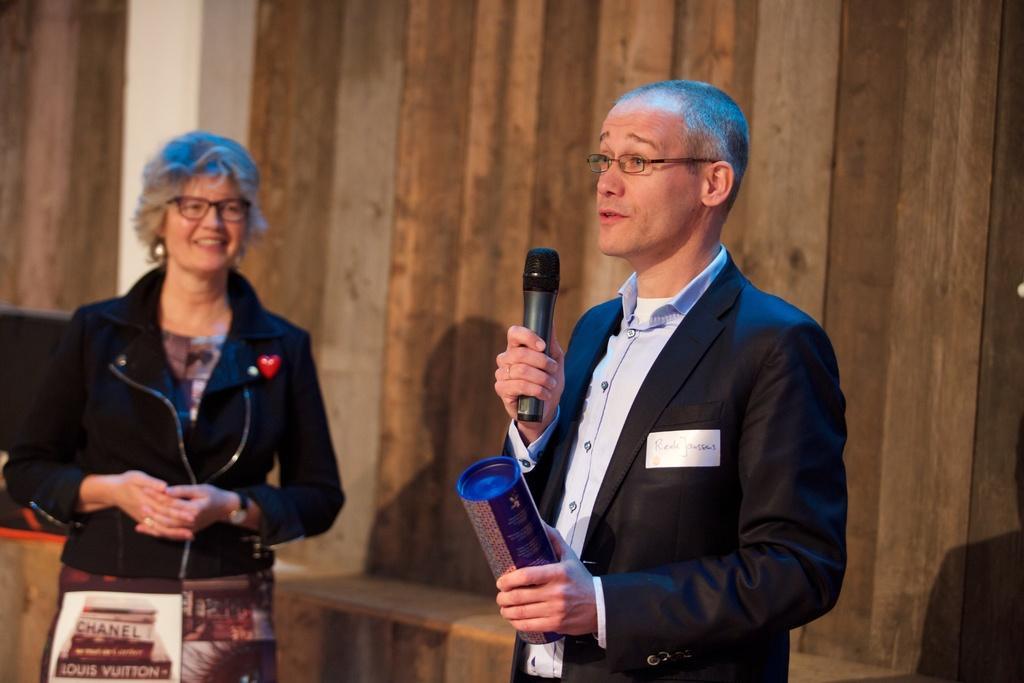In one or two sentences, can you explain what this image depicts? Here we can see that a man is standing on the floor and holding a microphone in his hand and he is speaking, and at beside a woman is standing and smiling, and at back here is the wall. 